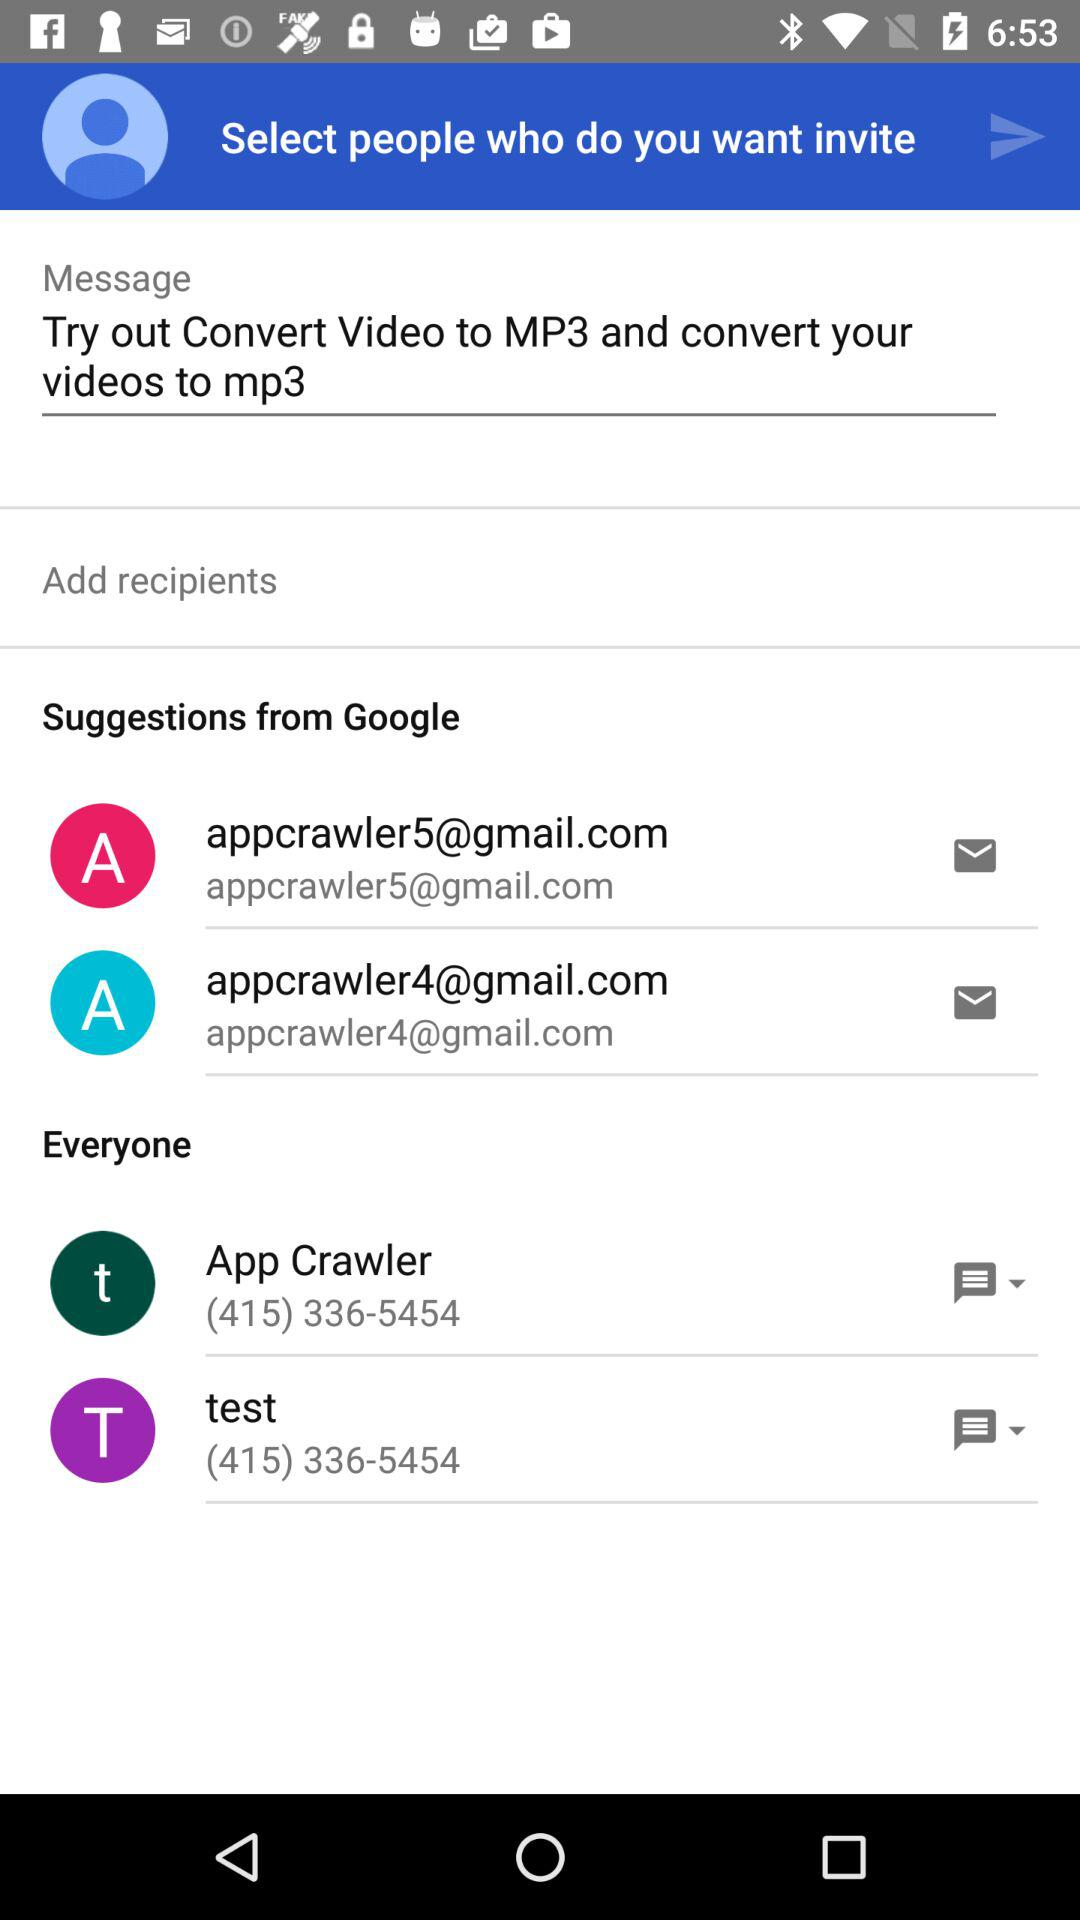What is the contact number for the test? The contact number for the test is (415) 336-5454. 